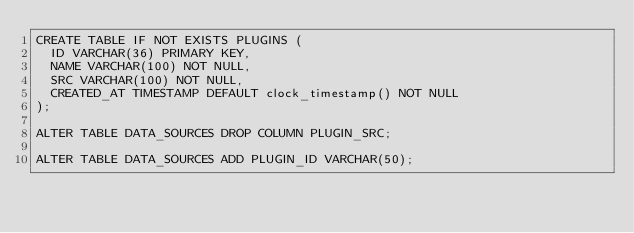Convert code to text. <code><loc_0><loc_0><loc_500><loc_500><_SQL_>CREATE TABLE IF NOT EXISTS PLUGINS (
	ID VARCHAR(36) PRIMARY KEY,
	NAME VARCHAR(100) NOT NULL,
	SRC VARCHAR(100) NOT NULL,
	CREATED_AT TIMESTAMP DEFAULT clock_timestamp() NOT NULL
);

ALTER TABLE DATA_SOURCES DROP COLUMN PLUGIN_SRC;

ALTER TABLE DATA_SOURCES ADD PLUGIN_ID VARCHAR(50);</code> 